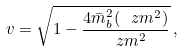Convert formula to latex. <formula><loc_0><loc_0><loc_500><loc_500>v = \sqrt { 1 - \frac { 4 { \bar { m } } ^ { 2 } _ { b } ( \ z m ^ { 2 } ) } { \ z m ^ { 2 } } } \, ,</formula> 